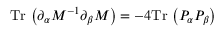Convert formula to latex. <formula><loc_0><loc_0><loc_500><loc_500>T r \, \left ( \partial _ { \alpha } M ^ { - 1 } \partial _ { \beta } M \right ) = - 4 T r \, \left ( P _ { \alpha } P _ { \beta } \right )</formula> 